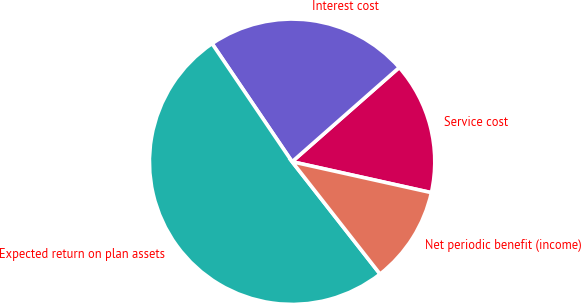Convert chart to OTSL. <chart><loc_0><loc_0><loc_500><loc_500><pie_chart><fcel>Service cost<fcel>Interest cost<fcel>Expected return on plan assets<fcel>Net periodic benefit (income)<nl><fcel>14.96%<fcel>22.99%<fcel>51.09%<fcel>10.95%<nl></chart> 